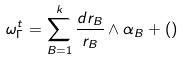Convert formula to latex. <formula><loc_0><loc_0><loc_500><loc_500>\omega _ { \Gamma } ^ { t } = \sum _ { B = 1 } ^ { k } \frac { d r _ { B } } { r _ { B } } \wedge \alpha _ { B } + ( )</formula> 